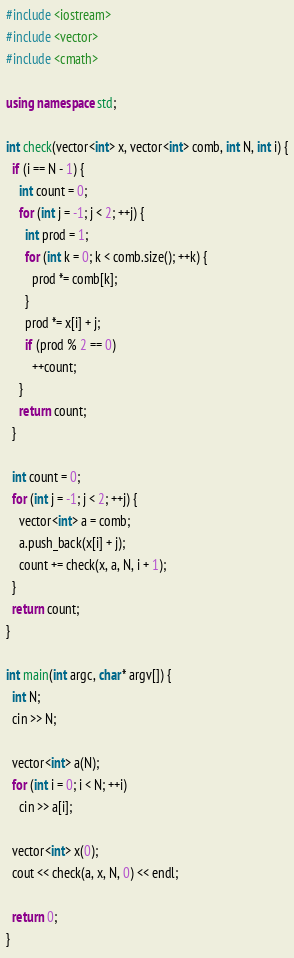Convert code to text. <code><loc_0><loc_0><loc_500><loc_500><_C++_>#include <iostream>
#include <vector>
#include <cmath>

using namespace std;

int check(vector<int> x, vector<int> comb, int N, int i) {
  if (i == N - 1) {
    int count = 0;
    for (int j = -1; j < 2; ++j) {
      int prod = 1;
      for (int k = 0; k < comb.size(); ++k) {
        prod *= comb[k];
      }
      prod *= x[i] + j;
      if (prod % 2 == 0)
        ++count;
    }
    return count;
  }

  int count = 0;
  for (int j = -1; j < 2; ++j) {
    vector<int> a = comb;
    a.push_back(x[i] + j);
    count += check(x, a, N, i + 1);
  }
  return count;
}

int main(int argc, char* argv[]) {
  int N;
  cin >> N;

  vector<int> a(N);
  for (int i = 0; i < N; ++i)
    cin >> a[i];

  vector<int> x(0);
  cout << check(a, x, N, 0) << endl;

  return 0;
}</code> 